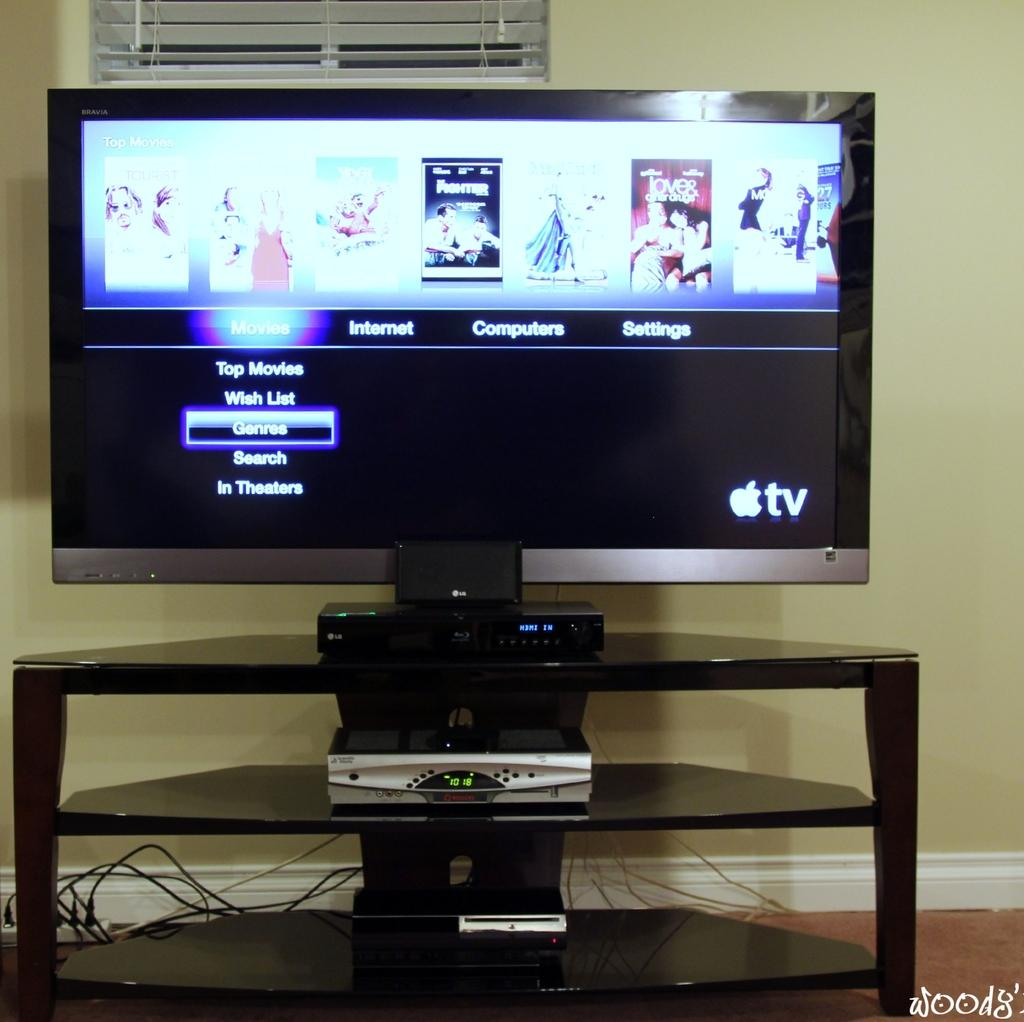<image>
Provide a brief description of the given image. An Apple TV screen shows a menu for different types of movies. 